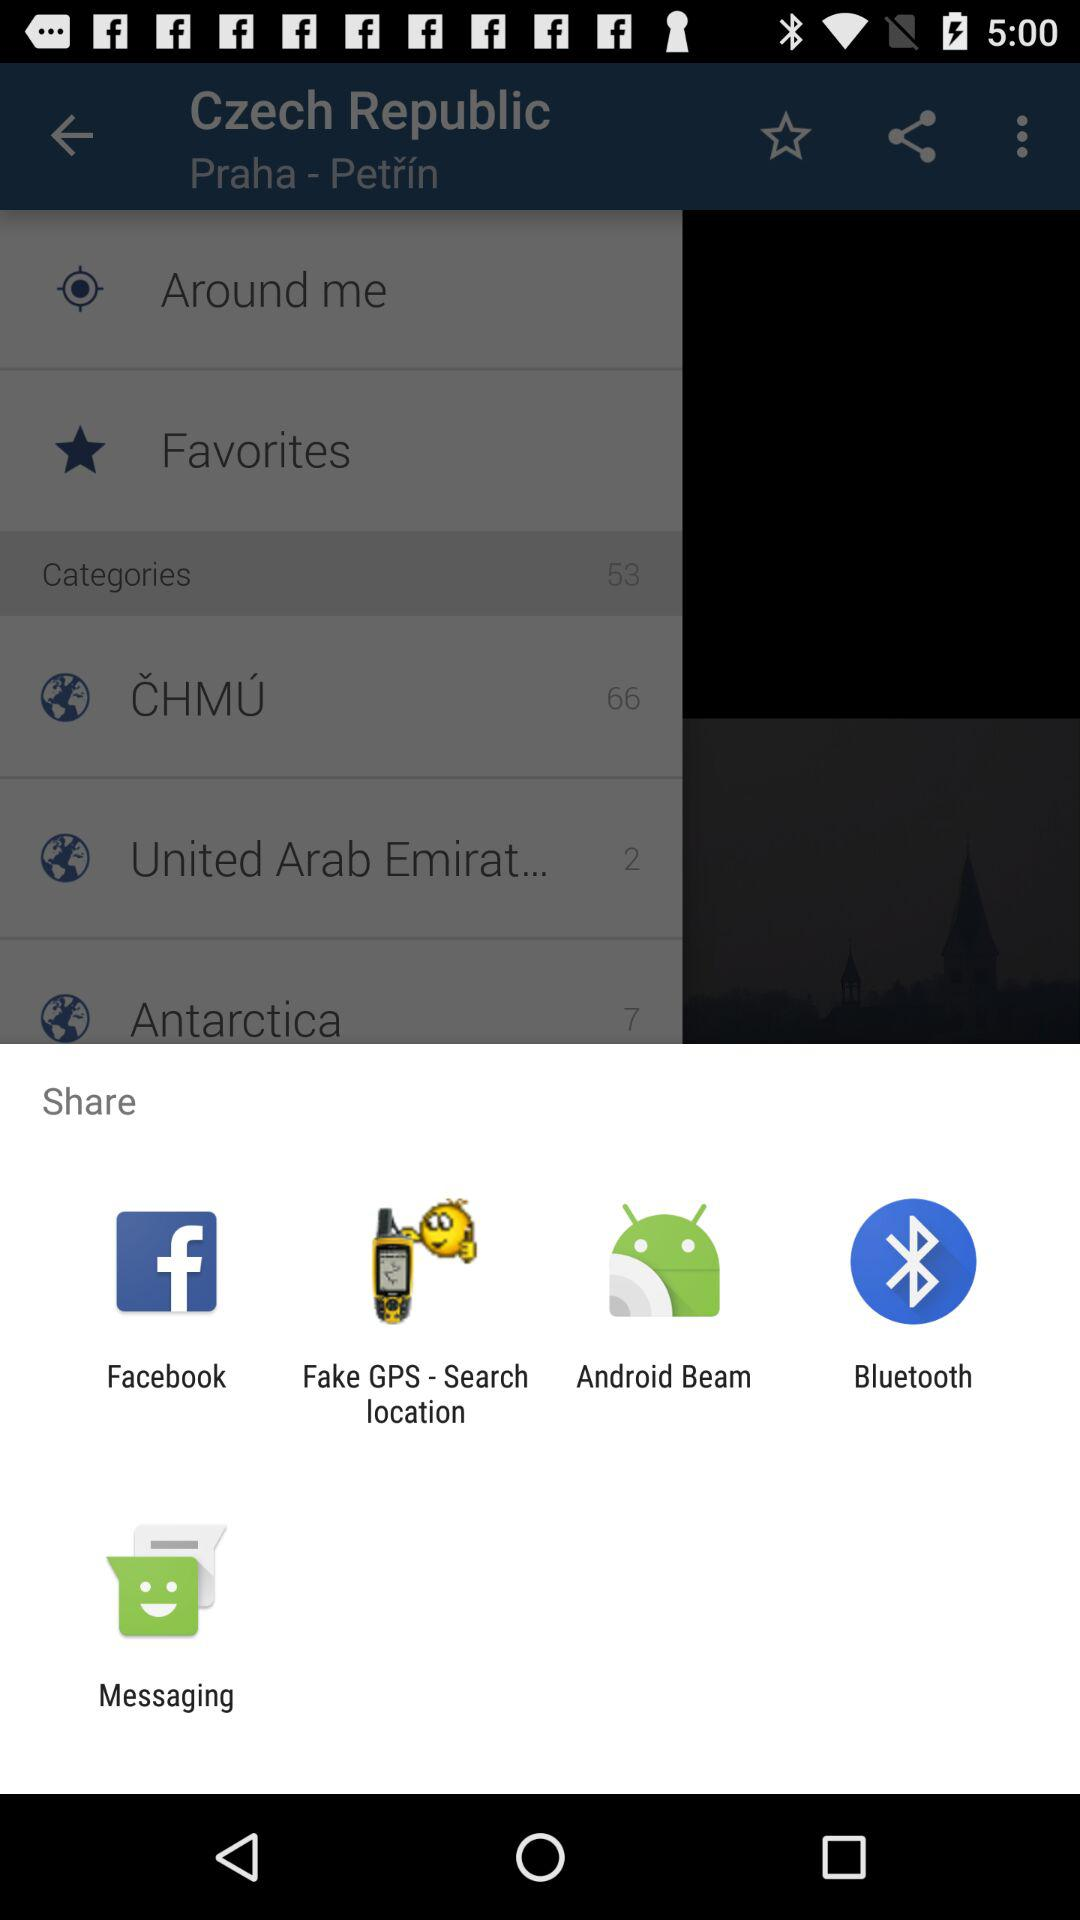What are the different applications through which we can share? The applications are "Facebook", "Fake GPS - Search location", "Android Beam", "Bluetooth" and "Messaging". 